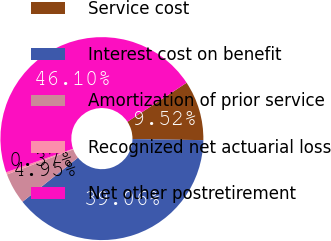<chart> <loc_0><loc_0><loc_500><loc_500><pie_chart><fcel>Service cost<fcel>Interest cost on benefit<fcel>Amortization of prior service<fcel>Recognized net actuarial loss<fcel>Net other postretirement<nl><fcel>9.52%<fcel>39.06%<fcel>4.95%<fcel>0.37%<fcel>46.1%<nl></chart> 